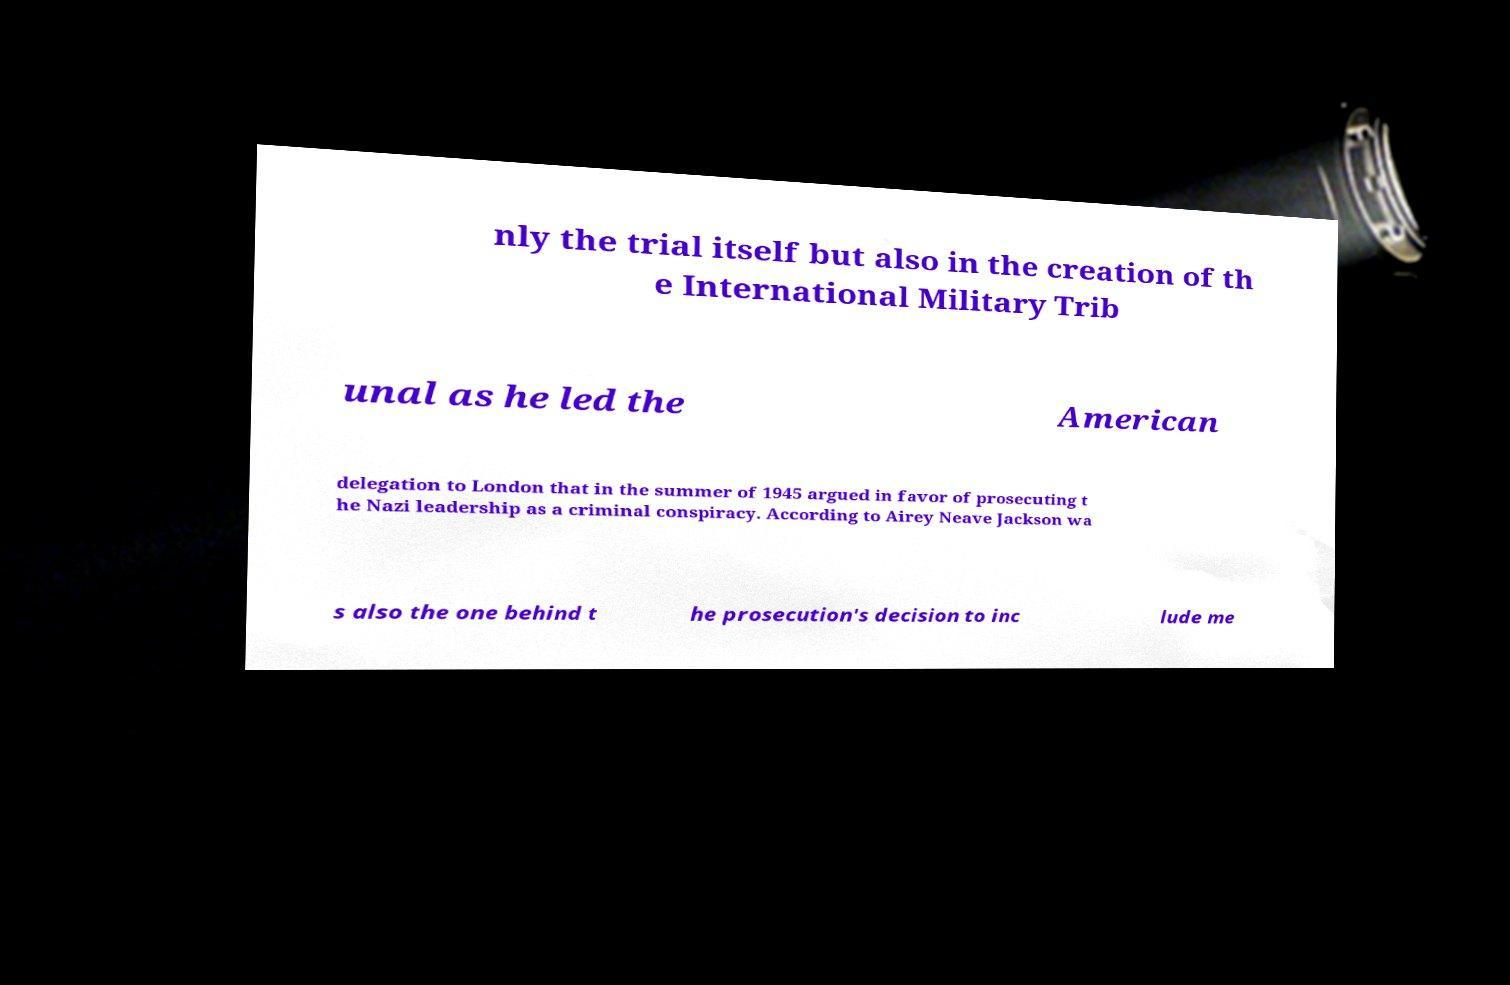There's text embedded in this image that I need extracted. Can you transcribe it verbatim? nly the trial itself but also in the creation of th e International Military Trib unal as he led the American delegation to London that in the summer of 1945 argued in favor of prosecuting t he Nazi leadership as a criminal conspiracy. According to Airey Neave Jackson wa s also the one behind t he prosecution's decision to inc lude me 